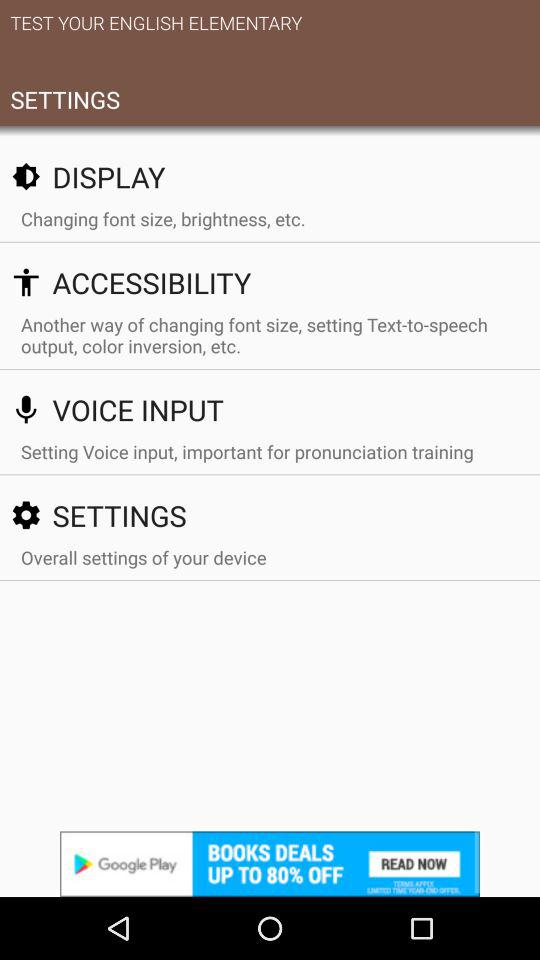How many items are in the Settings menu?
Answer the question using a single word or phrase. 4 